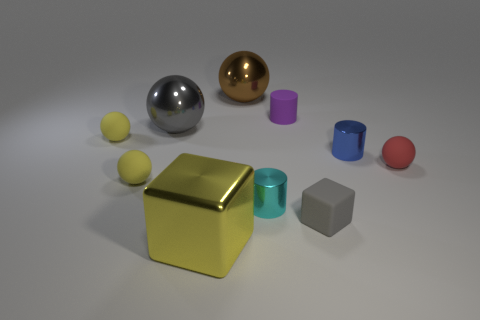What might be the purpose of arranging these objects in this way? The arrangement of these objects might be intended for a study in color relationships, material contrast, and geometric form. This type of setup is often used in 3D modeling and rendering to demonstrate rendering techniques, lighting, and texturing capabilities. Could this image be used for educational purposes? Absolutely, this image could serve as a visual aid in teaching about 3D modeling, geometry, physics of light, and material studies. It showcases fundamental principles that are critical to various fields such as graphic design, visual arts, and computer graphics education. 